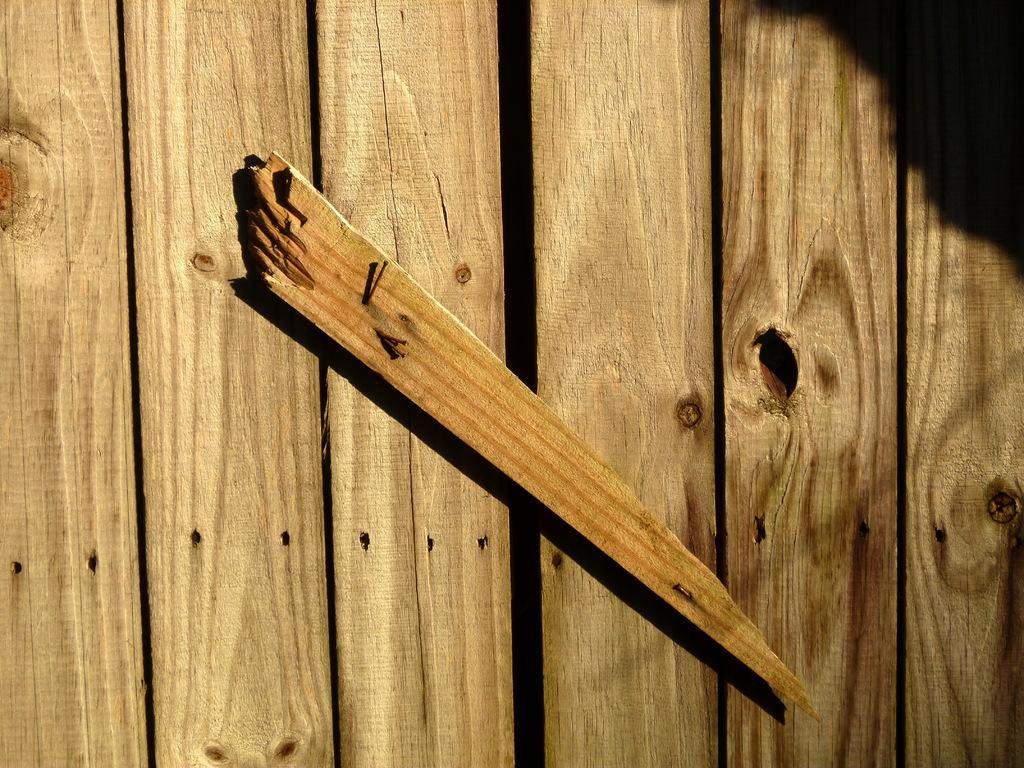What type of material is used for the wall in the image? The wall in the image is made of wooden planks. Is there anything attached to the wooden planks wall? Yes, there is a wooden stick fixed on the wall in the image. What types of toys can be seen scattered on the field in the image? There is no field or toys present in the image; it only features a wooden planks wall and a wooden stick fixed on it. How many nails are used to attach the wooden stick to the wall in the image? The provided facts do not mention the use of nails or the method of attaching the wooden stick to the wall, so we cannot determine the number of nails used. 